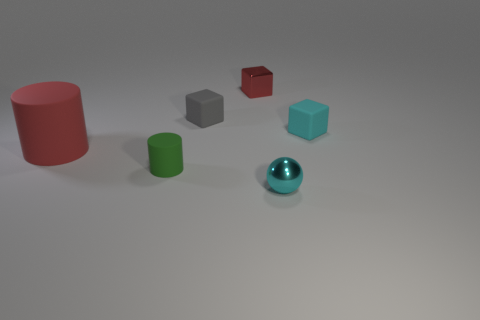Is the material of the tiny cube that is on the right side of the tiny red block the same as the big red cylinder that is to the left of the small cyan ball?
Offer a terse response. Yes. The big cylinder is what color?
Provide a succinct answer. Red. How big is the block on the right side of the tiny cyan object in front of the cylinder that is to the right of the big red matte cylinder?
Your answer should be compact. Small. What number of other objects are there of the same size as the cyan shiny thing?
Give a very brief answer. 4. What number of large things are made of the same material as the large red cylinder?
Provide a short and direct response. 0. There is a small object that is behind the tiny gray rubber block; what is its shape?
Keep it short and to the point. Cube. Does the big red object have the same material as the cyan thing that is behind the tiny green matte cylinder?
Offer a very short reply. Yes. Are any tiny cylinders visible?
Offer a very short reply. Yes. Are there any rubber cubes that are to the left of the matte block that is to the right of the tiny red object that is to the right of the red rubber cylinder?
Provide a succinct answer. Yes. What number of big objects are red cylinders or red metallic blocks?
Ensure brevity in your answer.  1. 